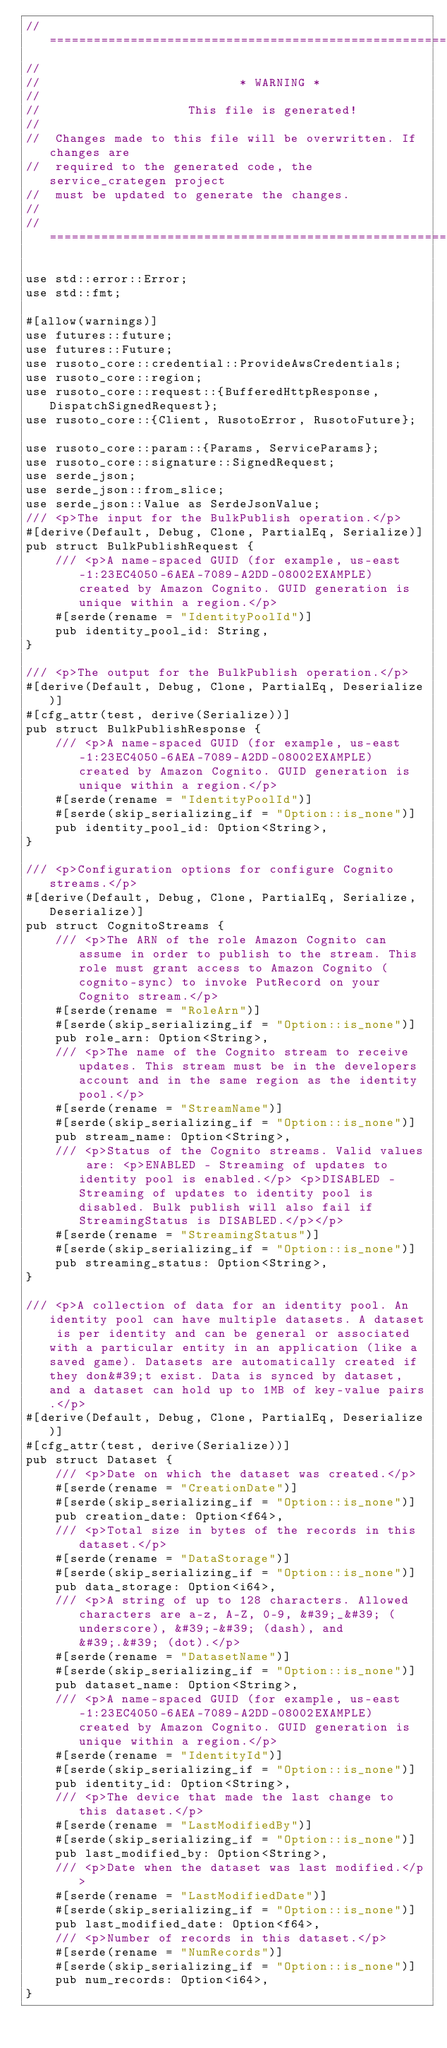<code> <loc_0><loc_0><loc_500><loc_500><_Rust_>// =================================================================
//
//                           * WARNING *
//
//                    This file is generated!
//
//  Changes made to this file will be overwritten. If changes are
//  required to the generated code, the service_crategen project
//  must be updated to generate the changes.
//
// =================================================================

use std::error::Error;
use std::fmt;

#[allow(warnings)]
use futures::future;
use futures::Future;
use rusoto_core::credential::ProvideAwsCredentials;
use rusoto_core::region;
use rusoto_core::request::{BufferedHttpResponse, DispatchSignedRequest};
use rusoto_core::{Client, RusotoError, RusotoFuture};

use rusoto_core::param::{Params, ServiceParams};
use rusoto_core::signature::SignedRequest;
use serde_json;
use serde_json::from_slice;
use serde_json::Value as SerdeJsonValue;
/// <p>The input for the BulkPublish operation.</p>
#[derive(Default, Debug, Clone, PartialEq, Serialize)]
pub struct BulkPublishRequest {
    /// <p>A name-spaced GUID (for example, us-east-1:23EC4050-6AEA-7089-A2DD-08002EXAMPLE) created by Amazon Cognito. GUID generation is unique within a region.</p>
    #[serde(rename = "IdentityPoolId")]
    pub identity_pool_id: String,
}

/// <p>The output for the BulkPublish operation.</p>
#[derive(Default, Debug, Clone, PartialEq, Deserialize)]
#[cfg_attr(test, derive(Serialize))]
pub struct BulkPublishResponse {
    /// <p>A name-spaced GUID (for example, us-east-1:23EC4050-6AEA-7089-A2DD-08002EXAMPLE) created by Amazon Cognito. GUID generation is unique within a region.</p>
    #[serde(rename = "IdentityPoolId")]
    #[serde(skip_serializing_if = "Option::is_none")]
    pub identity_pool_id: Option<String>,
}

/// <p>Configuration options for configure Cognito streams.</p>
#[derive(Default, Debug, Clone, PartialEq, Serialize, Deserialize)]
pub struct CognitoStreams {
    /// <p>The ARN of the role Amazon Cognito can assume in order to publish to the stream. This role must grant access to Amazon Cognito (cognito-sync) to invoke PutRecord on your Cognito stream.</p>
    #[serde(rename = "RoleArn")]
    #[serde(skip_serializing_if = "Option::is_none")]
    pub role_arn: Option<String>,
    /// <p>The name of the Cognito stream to receive updates. This stream must be in the developers account and in the same region as the identity pool.</p>
    #[serde(rename = "StreamName")]
    #[serde(skip_serializing_if = "Option::is_none")]
    pub stream_name: Option<String>,
    /// <p>Status of the Cognito streams. Valid values are: <p>ENABLED - Streaming of updates to identity pool is enabled.</p> <p>DISABLED - Streaming of updates to identity pool is disabled. Bulk publish will also fail if StreamingStatus is DISABLED.</p></p>
    #[serde(rename = "StreamingStatus")]
    #[serde(skip_serializing_if = "Option::is_none")]
    pub streaming_status: Option<String>,
}

/// <p>A collection of data for an identity pool. An identity pool can have multiple datasets. A dataset is per identity and can be general or associated with a particular entity in an application (like a saved game). Datasets are automatically created if they don&#39;t exist. Data is synced by dataset, and a dataset can hold up to 1MB of key-value pairs.</p>
#[derive(Default, Debug, Clone, PartialEq, Deserialize)]
#[cfg_attr(test, derive(Serialize))]
pub struct Dataset {
    /// <p>Date on which the dataset was created.</p>
    #[serde(rename = "CreationDate")]
    #[serde(skip_serializing_if = "Option::is_none")]
    pub creation_date: Option<f64>,
    /// <p>Total size in bytes of the records in this dataset.</p>
    #[serde(rename = "DataStorage")]
    #[serde(skip_serializing_if = "Option::is_none")]
    pub data_storage: Option<i64>,
    /// <p>A string of up to 128 characters. Allowed characters are a-z, A-Z, 0-9, &#39;_&#39; (underscore), &#39;-&#39; (dash), and &#39;.&#39; (dot).</p>
    #[serde(rename = "DatasetName")]
    #[serde(skip_serializing_if = "Option::is_none")]
    pub dataset_name: Option<String>,
    /// <p>A name-spaced GUID (for example, us-east-1:23EC4050-6AEA-7089-A2DD-08002EXAMPLE) created by Amazon Cognito. GUID generation is unique within a region.</p>
    #[serde(rename = "IdentityId")]
    #[serde(skip_serializing_if = "Option::is_none")]
    pub identity_id: Option<String>,
    /// <p>The device that made the last change to this dataset.</p>
    #[serde(rename = "LastModifiedBy")]
    #[serde(skip_serializing_if = "Option::is_none")]
    pub last_modified_by: Option<String>,
    /// <p>Date when the dataset was last modified.</p>
    #[serde(rename = "LastModifiedDate")]
    #[serde(skip_serializing_if = "Option::is_none")]
    pub last_modified_date: Option<f64>,
    /// <p>Number of records in this dataset.</p>
    #[serde(rename = "NumRecords")]
    #[serde(skip_serializing_if = "Option::is_none")]
    pub num_records: Option<i64>,
}
</code> 